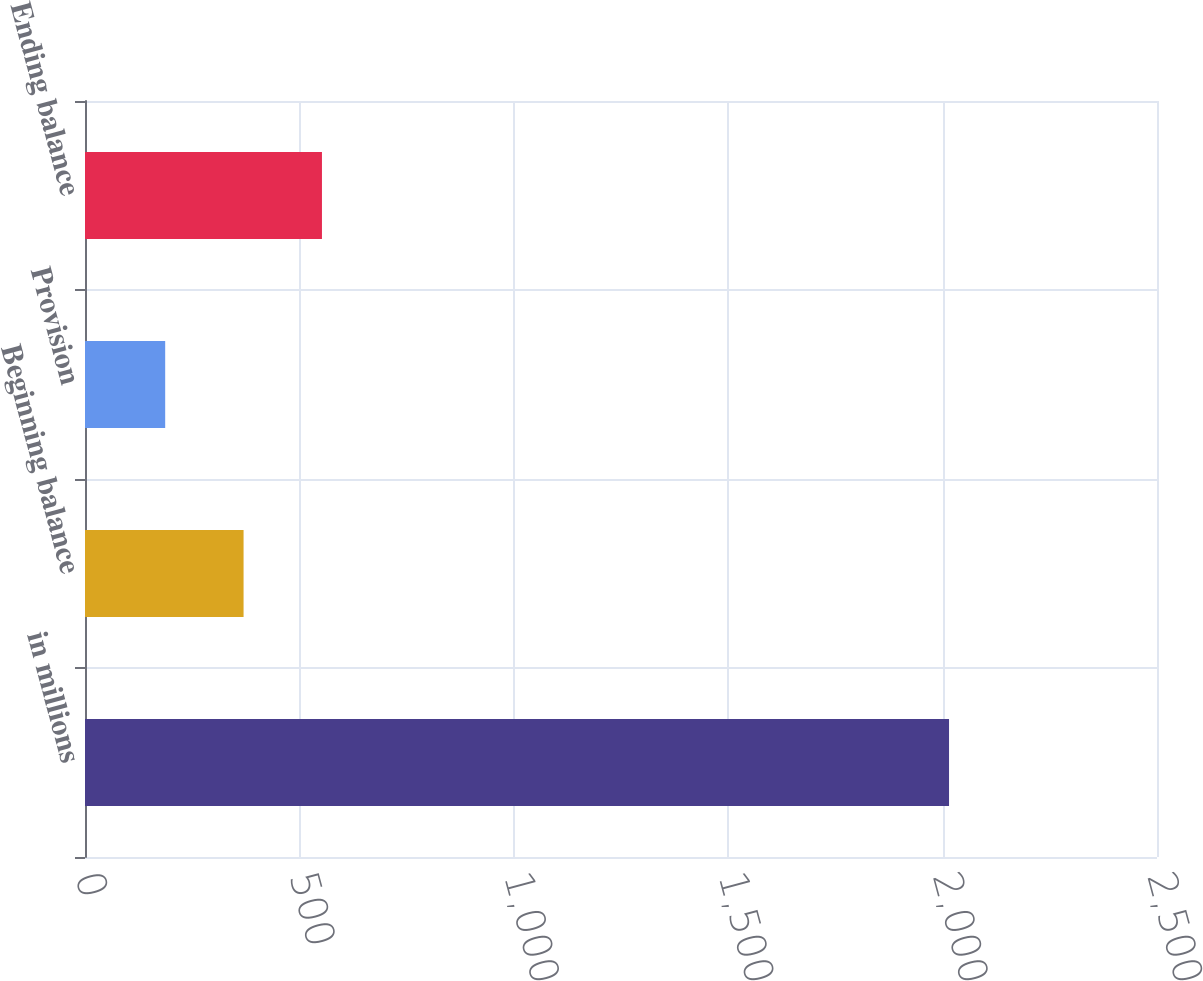Convert chart. <chart><loc_0><loc_0><loc_500><loc_500><bar_chart><fcel>in millions<fcel>Beginning balance<fcel>Provision<fcel>Ending balance<nl><fcel>2015<fcel>369.8<fcel>187<fcel>552.6<nl></chart> 